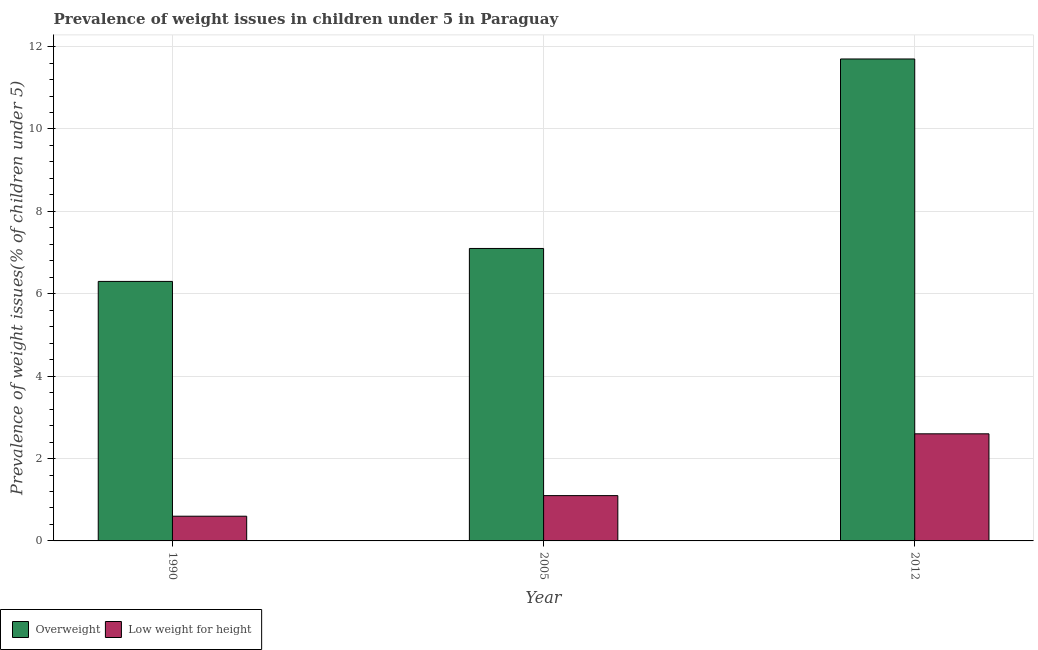How many groups of bars are there?
Offer a very short reply. 3. Are the number of bars on each tick of the X-axis equal?
Offer a terse response. Yes. How many bars are there on the 3rd tick from the left?
Make the answer very short. 2. What is the percentage of overweight children in 1990?
Offer a terse response. 6.3. Across all years, what is the maximum percentage of overweight children?
Your answer should be compact. 11.7. Across all years, what is the minimum percentage of underweight children?
Offer a very short reply. 0.6. In which year was the percentage of overweight children minimum?
Provide a short and direct response. 1990. What is the total percentage of overweight children in the graph?
Offer a terse response. 25.1. What is the difference between the percentage of underweight children in 1990 and that in 2012?
Provide a short and direct response. -2. What is the difference between the percentage of overweight children in 2005 and the percentage of underweight children in 2012?
Give a very brief answer. -4.6. What is the average percentage of overweight children per year?
Give a very brief answer. 8.37. What is the ratio of the percentage of underweight children in 1990 to that in 2012?
Offer a terse response. 0.23. What is the difference between the highest and the second highest percentage of overweight children?
Offer a terse response. 4.6. What is the difference between the highest and the lowest percentage of overweight children?
Provide a short and direct response. 5.4. In how many years, is the percentage of underweight children greater than the average percentage of underweight children taken over all years?
Your answer should be compact. 1. Is the sum of the percentage of underweight children in 1990 and 2005 greater than the maximum percentage of overweight children across all years?
Ensure brevity in your answer.  No. What does the 2nd bar from the left in 1990 represents?
Make the answer very short. Low weight for height. What does the 1st bar from the right in 2005 represents?
Keep it short and to the point. Low weight for height. What is the difference between two consecutive major ticks on the Y-axis?
Offer a very short reply. 2. What is the title of the graph?
Your response must be concise. Prevalence of weight issues in children under 5 in Paraguay. What is the label or title of the X-axis?
Keep it short and to the point. Year. What is the label or title of the Y-axis?
Your answer should be very brief. Prevalence of weight issues(% of children under 5). What is the Prevalence of weight issues(% of children under 5) in Overweight in 1990?
Provide a succinct answer. 6.3. What is the Prevalence of weight issues(% of children under 5) in Low weight for height in 1990?
Offer a terse response. 0.6. What is the Prevalence of weight issues(% of children under 5) of Overweight in 2005?
Offer a terse response. 7.1. What is the Prevalence of weight issues(% of children under 5) of Low weight for height in 2005?
Your answer should be compact. 1.1. What is the Prevalence of weight issues(% of children under 5) of Overweight in 2012?
Provide a succinct answer. 11.7. What is the Prevalence of weight issues(% of children under 5) in Low weight for height in 2012?
Your answer should be compact. 2.6. Across all years, what is the maximum Prevalence of weight issues(% of children under 5) of Overweight?
Your answer should be compact. 11.7. Across all years, what is the maximum Prevalence of weight issues(% of children under 5) of Low weight for height?
Offer a terse response. 2.6. Across all years, what is the minimum Prevalence of weight issues(% of children under 5) of Overweight?
Provide a succinct answer. 6.3. Across all years, what is the minimum Prevalence of weight issues(% of children under 5) in Low weight for height?
Provide a short and direct response. 0.6. What is the total Prevalence of weight issues(% of children under 5) in Overweight in the graph?
Ensure brevity in your answer.  25.1. What is the total Prevalence of weight issues(% of children under 5) in Low weight for height in the graph?
Offer a terse response. 4.3. What is the difference between the Prevalence of weight issues(% of children under 5) in Overweight in 1990 and that in 2005?
Offer a very short reply. -0.8. What is the difference between the Prevalence of weight issues(% of children under 5) of Overweight in 1990 and that in 2012?
Offer a terse response. -5.4. What is the difference between the Prevalence of weight issues(% of children under 5) in Low weight for height in 2005 and that in 2012?
Provide a short and direct response. -1.5. What is the difference between the Prevalence of weight issues(% of children under 5) of Overweight in 1990 and the Prevalence of weight issues(% of children under 5) of Low weight for height in 2005?
Ensure brevity in your answer.  5.2. What is the difference between the Prevalence of weight issues(% of children under 5) of Overweight in 2005 and the Prevalence of weight issues(% of children under 5) of Low weight for height in 2012?
Offer a terse response. 4.5. What is the average Prevalence of weight issues(% of children under 5) in Overweight per year?
Give a very brief answer. 8.37. What is the average Prevalence of weight issues(% of children under 5) in Low weight for height per year?
Your response must be concise. 1.43. What is the ratio of the Prevalence of weight issues(% of children under 5) in Overweight in 1990 to that in 2005?
Ensure brevity in your answer.  0.89. What is the ratio of the Prevalence of weight issues(% of children under 5) of Low weight for height in 1990 to that in 2005?
Your answer should be compact. 0.55. What is the ratio of the Prevalence of weight issues(% of children under 5) in Overweight in 1990 to that in 2012?
Your answer should be very brief. 0.54. What is the ratio of the Prevalence of weight issues(% of children under 5) of Low weight for height in 1990 to that in 2012?
Keep it short and to the point. 0.23. What is the ratio of the Prevalence of weight issues(% of children under 5) in Overweight in 2005 to that in 2012?
Ensure brevity in your answer.  0.61. What is the ratio of the Prevalence of weight issues(% of children under 5) in Low weight for height in 2005 to that in 2012?
Your response must be concise. 0.42. What is the difference between the highest and the second highest Prevalence of weight issues(% of children under 5) in Overweight?
Ensure brevity in your answer.  4.6. 